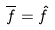Convert formula to latex. <formula><loc_0><loc_0><loc_500><loc_500>\overline { f } = \hat { f }</formula> 